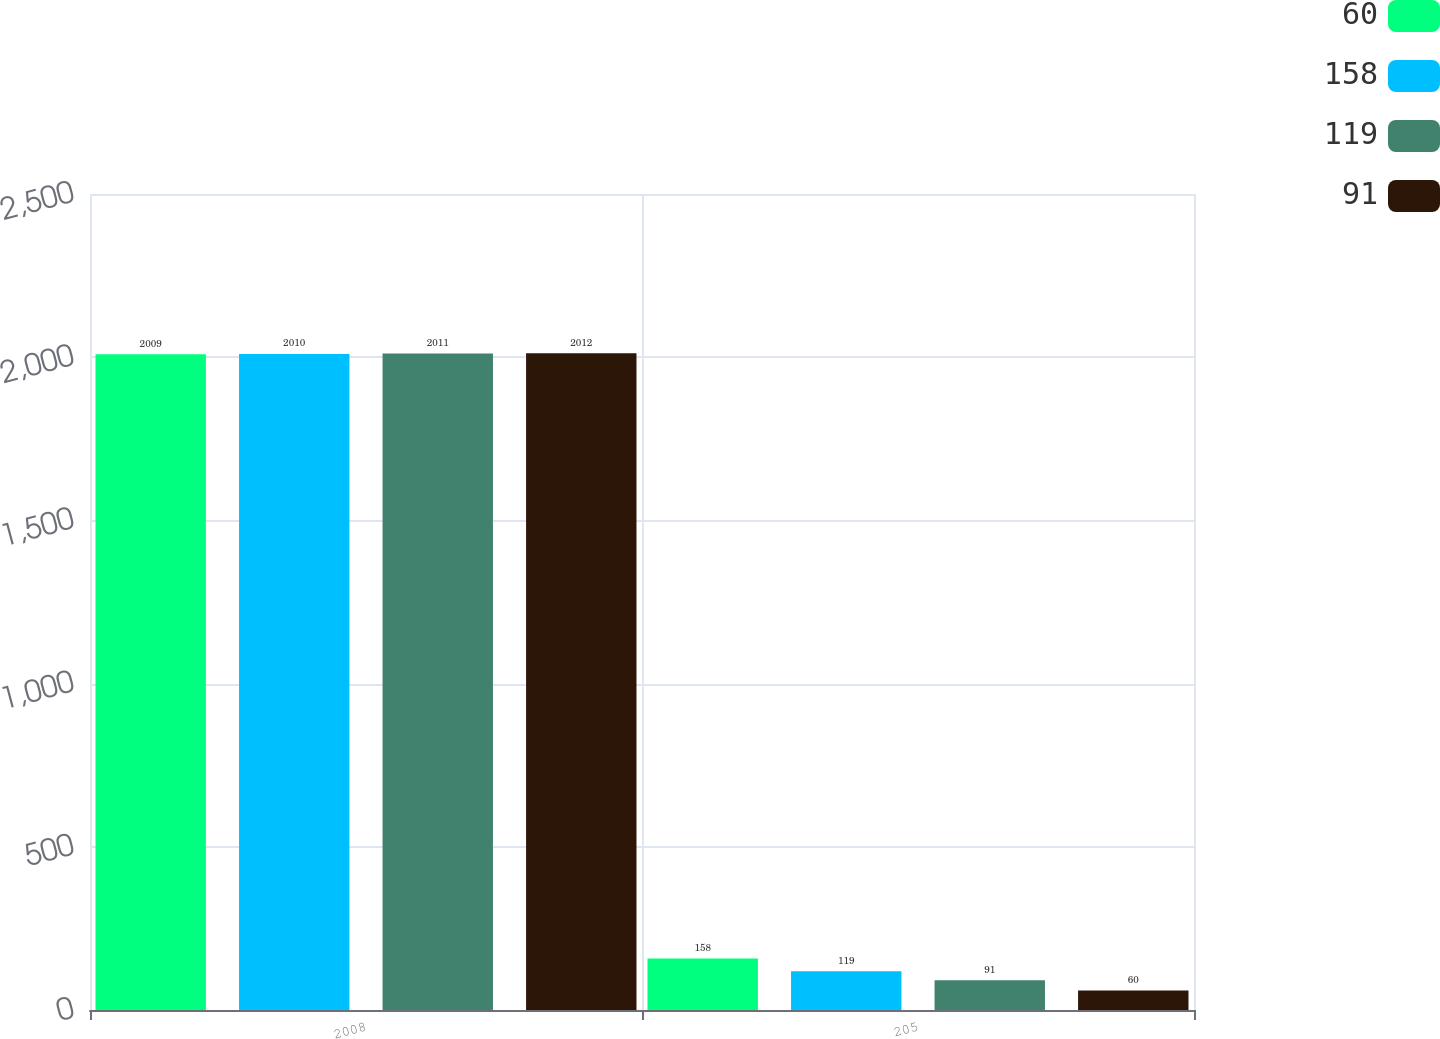<chart> <loc_0><loc_0><loc_500><loc_500><stacked_bar_chart><ecel><fcel>2008<fcel>205<nl><fcel>60<fcel>2009<fcel>158<nl><fcel>158<fcel>2010<fcel>119<nl><fcel>119<fcel>2011<fcel>91<nl><fcel>91<fcel>2012<fcel>60<nl></chart> 